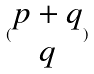Convert formula to latex. <formula><loc_0><loc_0><loc_500><loc_500>( \begin{matrix} p + q \\ q \end{matrix} )</formula> 